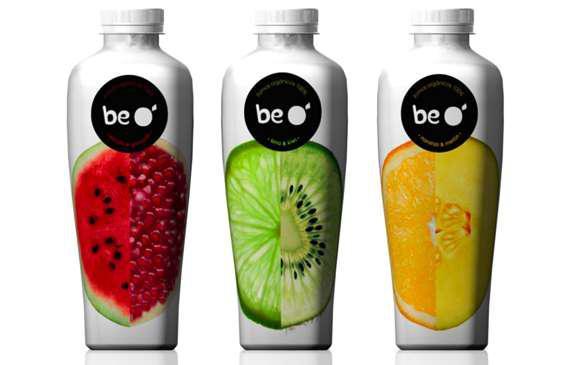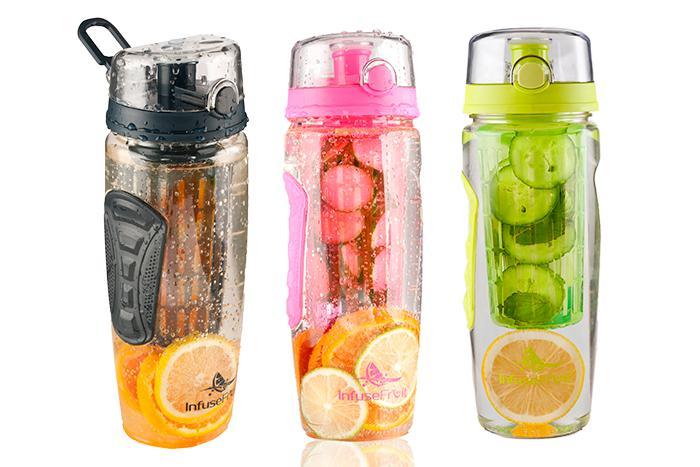The first image is the image on the left, the second image is the image on the right. Evaluate the accuracy of this statement regarding the images: "There are fruits near the glasses in one of the images.". Is it true? Answer yes or no. No. 